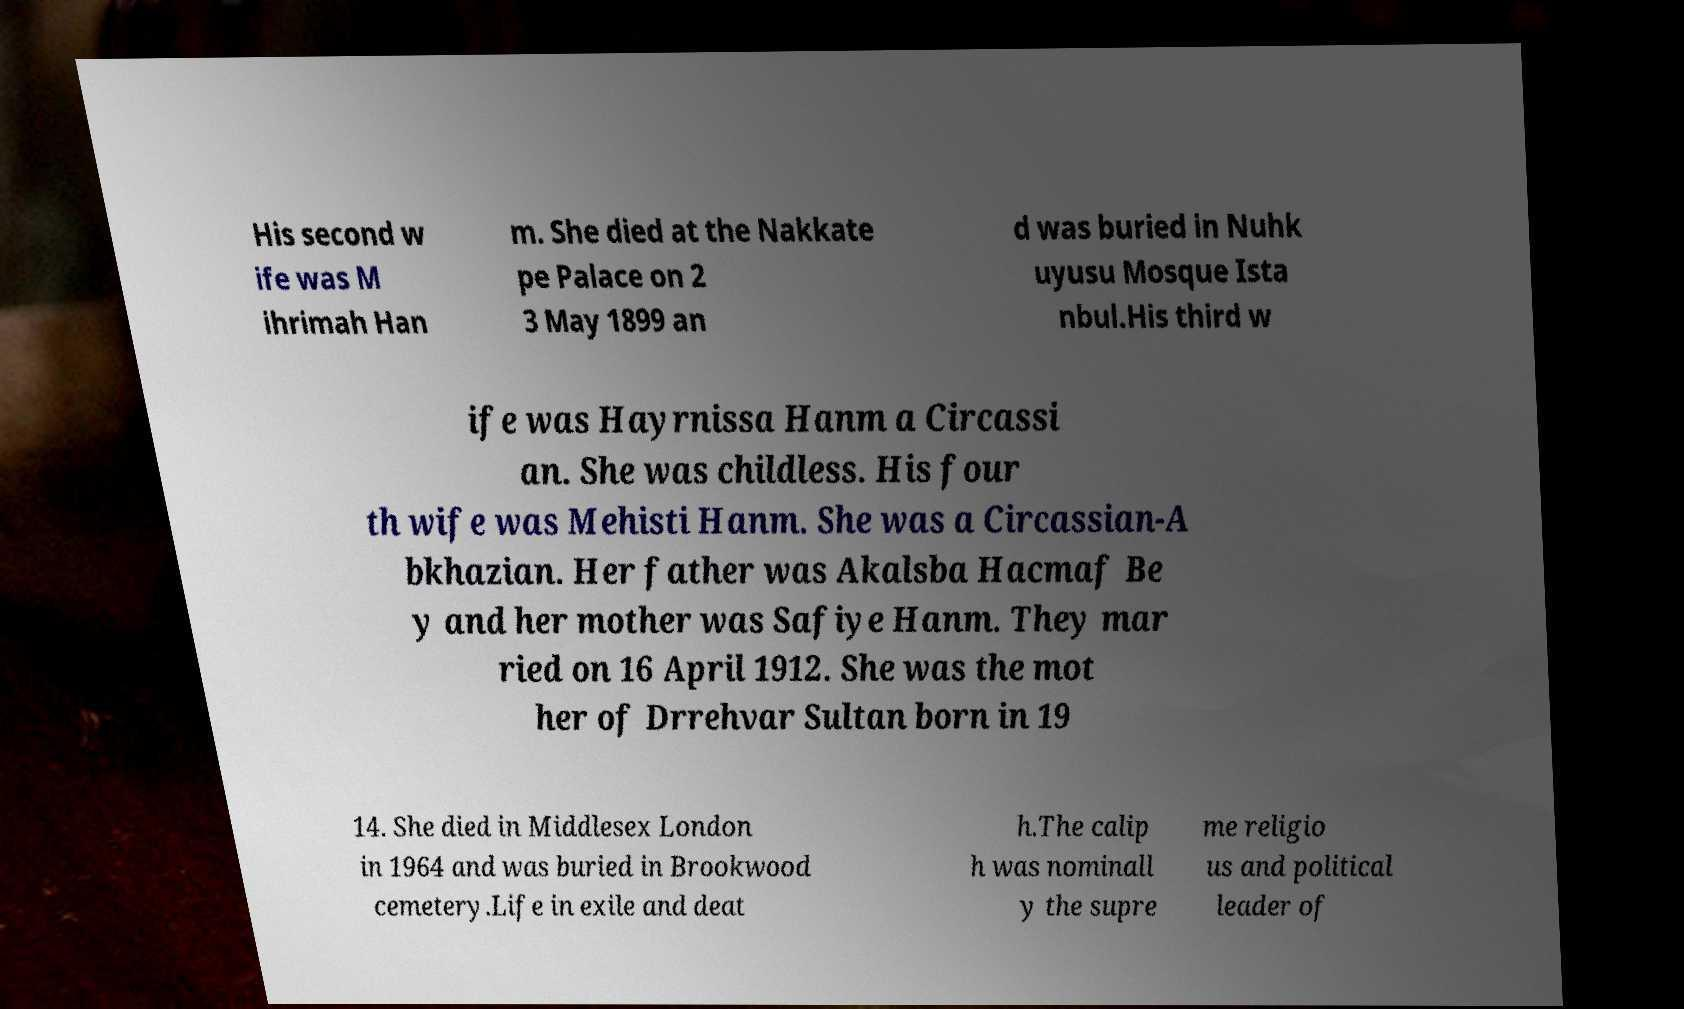Can you accurately transcribe the text from the provided image for me? His second w ife was M ihrimah Han m. She died at the Nakkate pe Palace on 2 3 May 1899 an d was buried in Nuhk uyusu Mosque Ista nbul.His third w ife was Hayrnissa Hanm a Circassi an. She was childless. His four th wife was Mehisti Hanm. She was a Circassian-A bkhazian. Her father was Akalsba Hacmaf Be y and her mother was Safiye Hanm. They mar ried on 16 April 1912. She was the mot her of Drrehvar Sultan born in 19 14. She died in Middlesex London in 1964 and was buried in Brookwood cemetery.Life in exile and deat h.The calip h was nominall y the supre me religio us and political leader of 